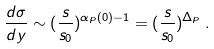<formula> <loc_0><loc_0><loc_500><loc_500>\frac { d \sigma } { d y } \sim ( \frac { s } { s _ { 0 } } ) ^ { \alpha _ { P } ( 0 ) - 1 } = ( \frac { s } { s _ { 0 } } ) ^ { \Delta _ { P } } \, .</formula> 